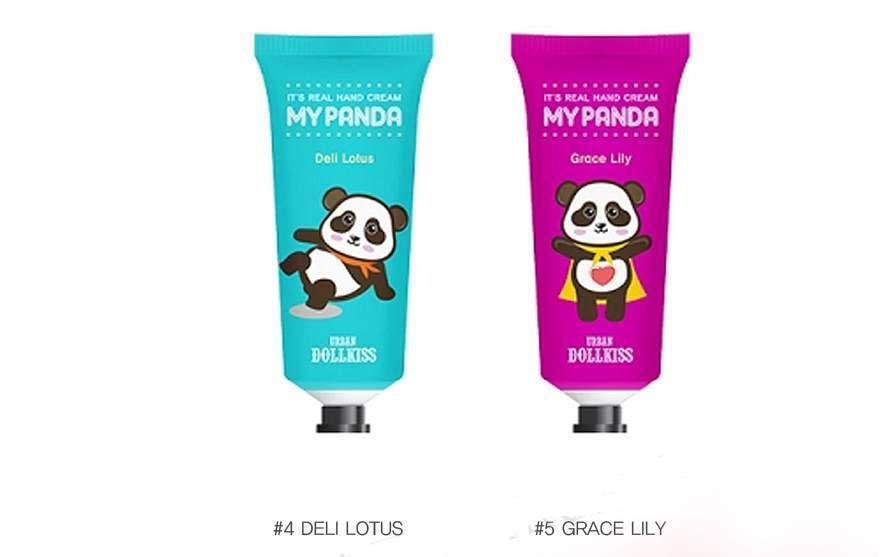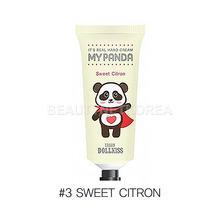The first image is the image on the left, the second image is the image on the right. Evaluate the accuracy of this statement regarding the images: "There are pink, red, and white bottles next to each other in that order, and also blue and purple in that order.". Is it true? Answer yes or no. No. The first image is the image on the left, the second image is the image on the right. Assess this claim about the two images: "Each image shows five tubes, each a different color and with assorted cartoon pandas on their fronts.". Correct or not? Answer yes or no. No. 